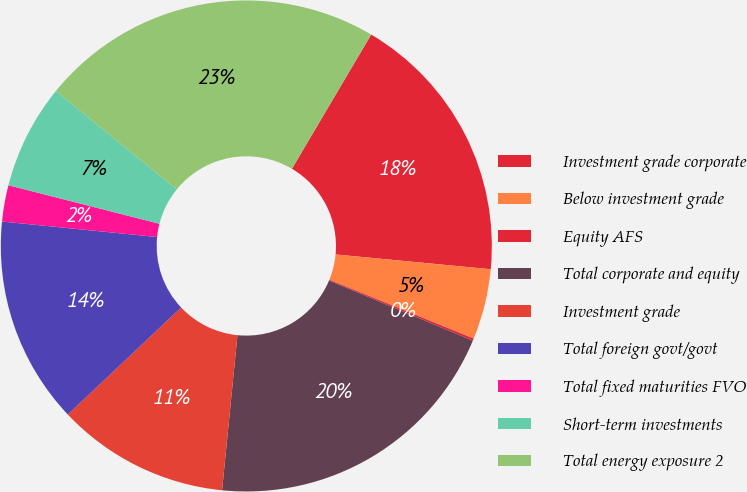Convert chart. <chart><loc_0><loc_0><loc_500><loc_500><pie_chart><fcel>Investment grade corporate<fcel>Below investment grade<fcel>Equity AFS<fcel>Total corporate and equity<fcel>Investment grade<fcel>Total foreign govt/govt<fcel>Total fixed maturities FVO<fcel>Short-term investments<fcel>Total energy exposure 2<nl><fcel>18.02%<fcel>4.64%<fcel>0.15%<fcel>20.27%<fcel>11.38%<fcel>13.63%<fcel>2.39%<fcel>6.89%<fcel>22.62%<nl></chart> 